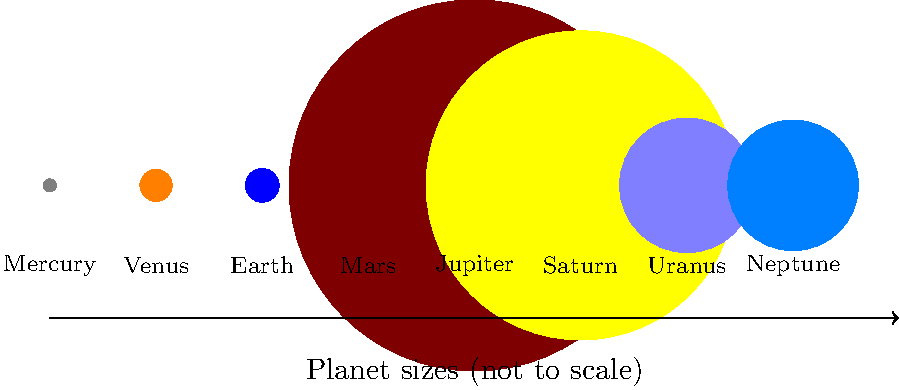Based on the scale diagram of planets in our solar system, which planet has the largest diameter and how does it compare to Earth's diameter in terms of magnitude? To answer this question efficiently, we'll follow these steps:

1. Identify the largest planet: From the diagram, we can visually determine that Jupiter is the largest planet.

2. Compare Jupiter's diameter to Earth's:
   - Jupiter's diameter: 139,820 km
   - Earth's diameter: 12,742 km

3. Calculate the ratio:
   $\frac{\text{Jupiter's diameter}}{\text{Earth's diameter}} = \frac{139,820}{12,742} \approx 10.97$

4. Round to the nearest whole number:
   10.97 rounds to 11

Therefore, Jupiter's diameter is approximately 11 times larger than Earth's diameter.

This comparison provides a quick and memorable metric for understanding the scale difference between the largest planet in our solar system and our home planet, which is crucial for assessing potential merger and acquisition opportunities in space-related industries.
Answer: Jupiter; 11 times larger than Earth's diameter 